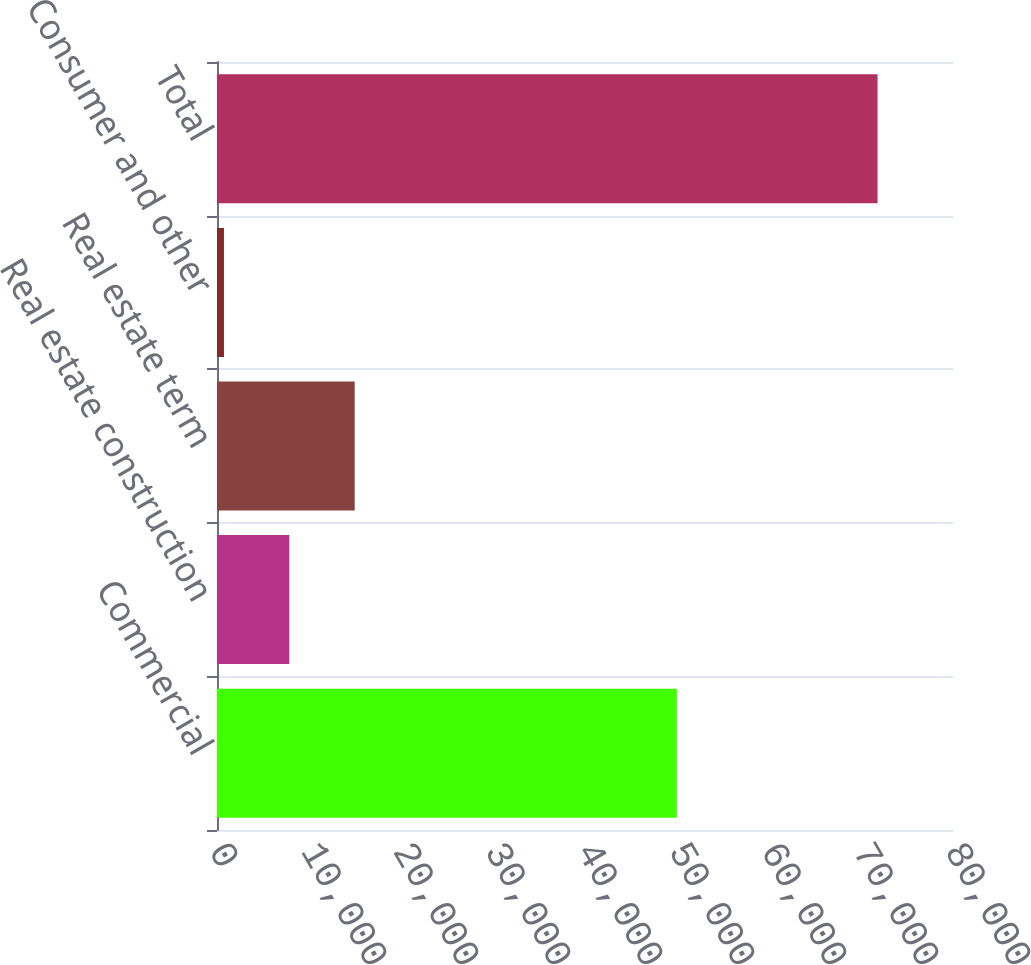Convert chart. <chart><loc_0><loc_0><loc_500><loc_500><bar_chart><fcel>Commercial<fcel>Real estate construction<fcel>Real estate term<fcel>Consumer and other<fcel>Total<nl><fcel>49985<fcel>7861.3<fcel>14965.6<fcel>757<fcel>71800<nl></chart> 